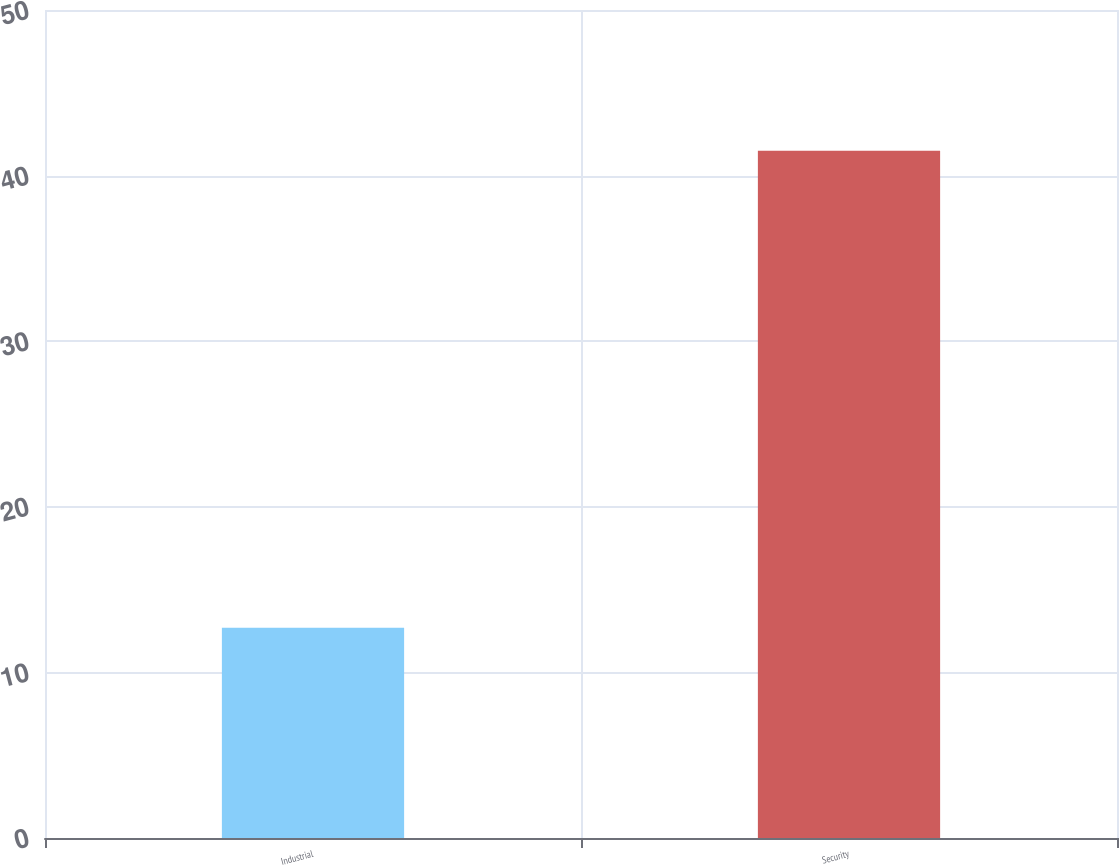Convert chart. <chart><loc_0><loc_0><loc_500><loc_500><bar_chart><fcel>Industrial<fcel>Security<nl><fcel>12.7<fcel>41.5<nl></chart> 